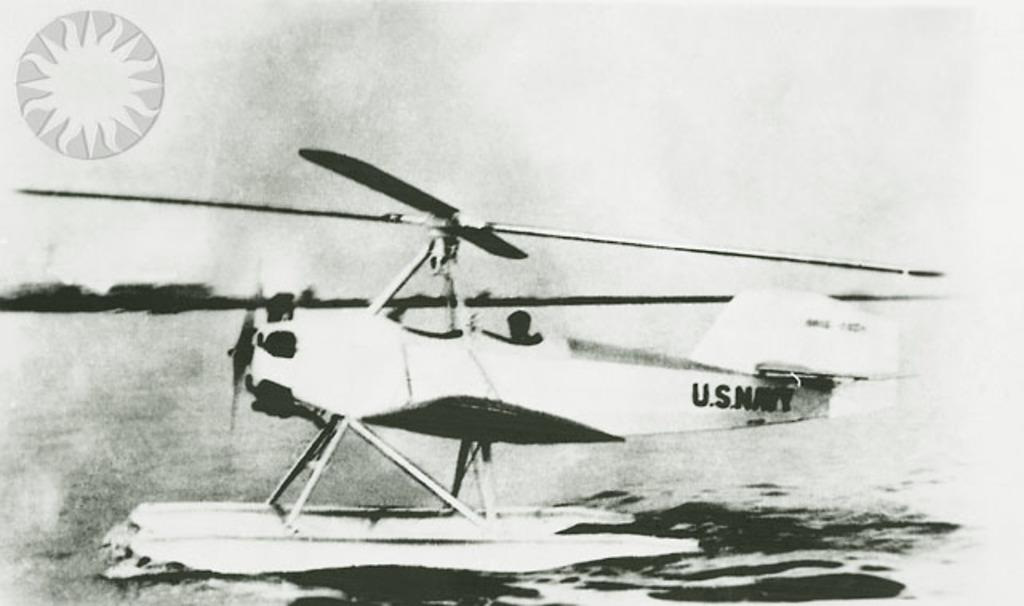<image>
Create a compact narrative representing the image presented. A single engine play with a helicopter rotor that says US NAVY on the side. 